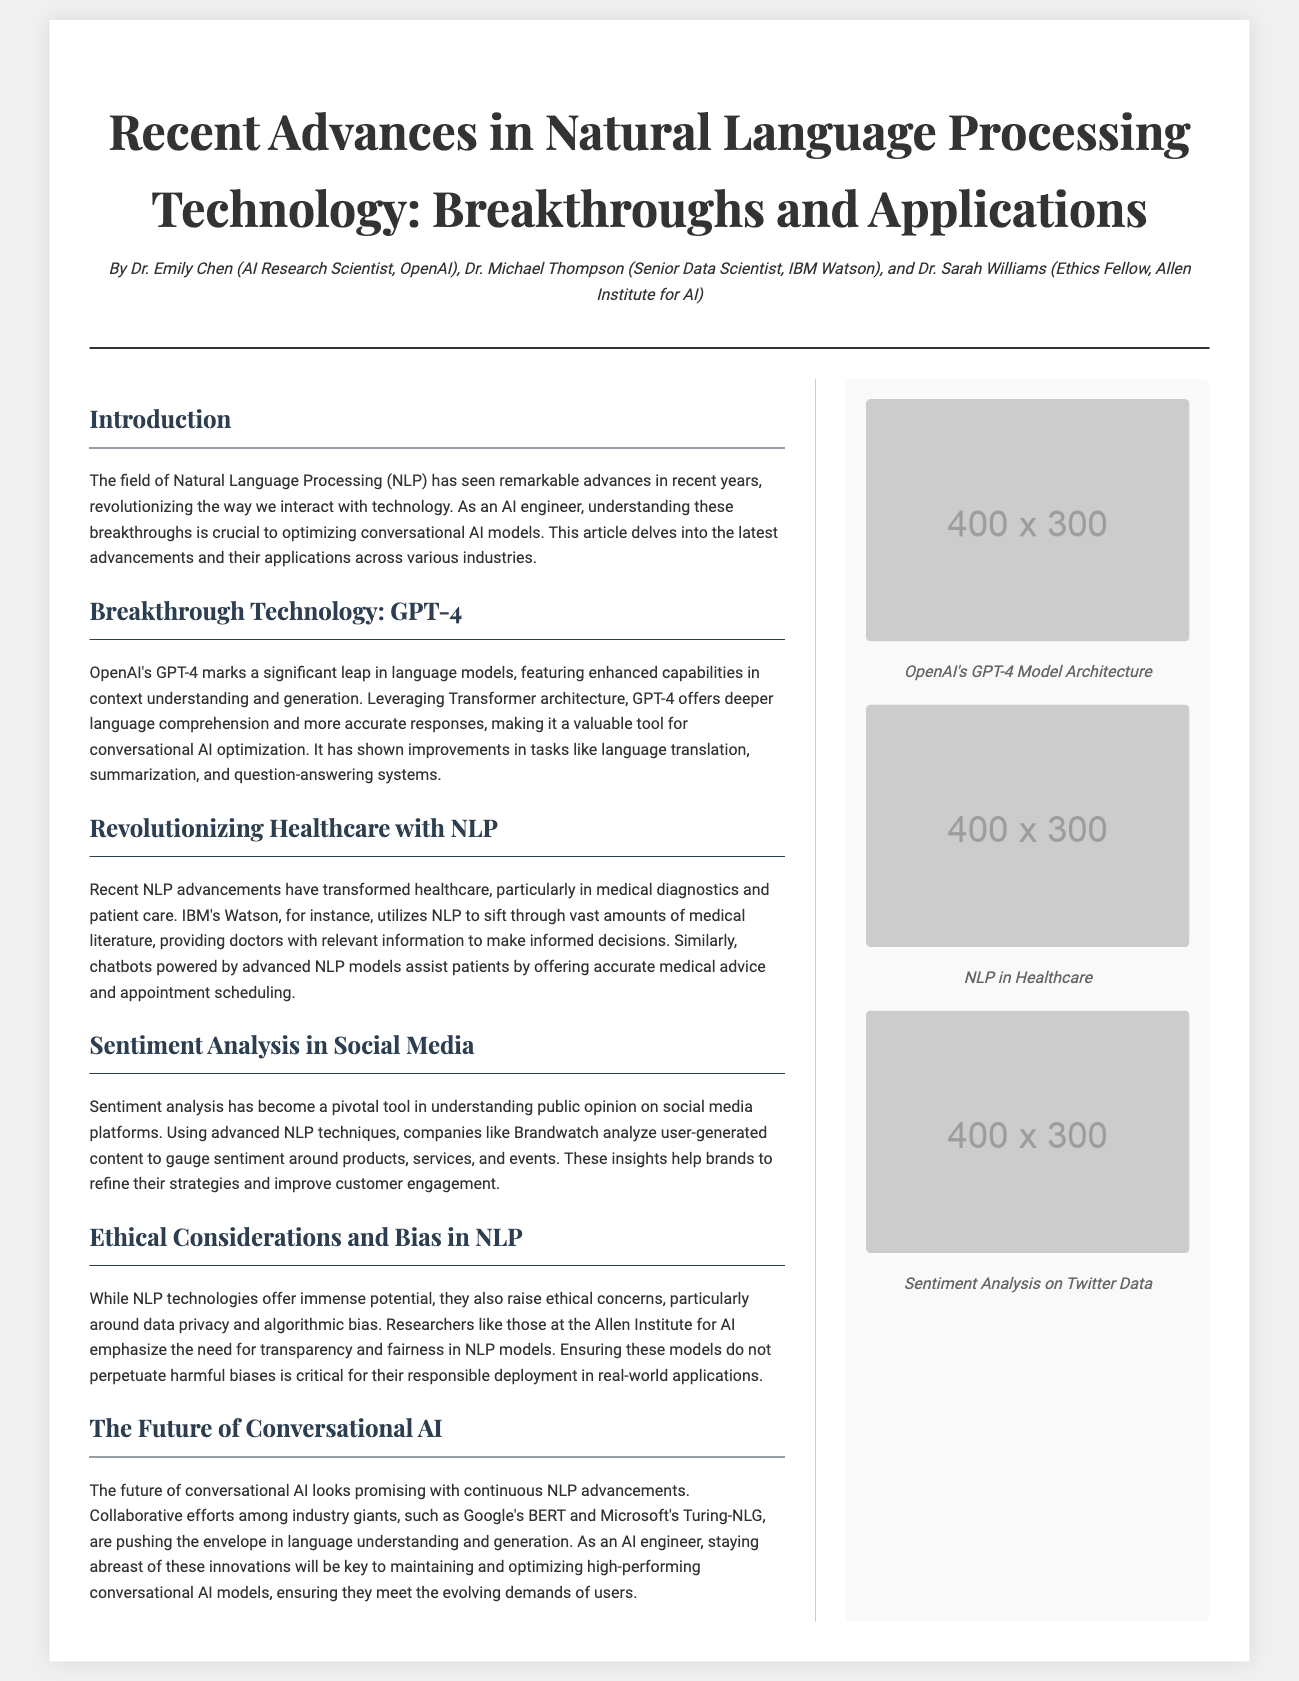What is the title of the article? The title of the article is found in the header section, which provides the central topic discussed.
Answer: Recent Advances in Natural Language Processing Technology: Breakthroughs and Applications Who is one of the authors? The authors are listed directly below the title, mentioning their names and affiliations.
Answer: Dr. Emily Chen What technology is mentioned as a breakthrough in the article? The article explicitly identifies the technology that represents a significant advancement in the field of NLP.
Answer: GPT-4 Which company utilizes NLP for medical diagnostics? The document specifies a company that is highlighted for its application of NLP in healthcare settings.
Answer: IBM What is one application of sentiment analysis mentioned? The article discusses how sentiment analysis is used in a specific context regarding user opinions.
Answer: Understanding public opinion on social media What ethical concern is raised regarding NLP technologies? The text addresses specific issues related to the responsible use of NLP technologies that can affect society.
Answer: Algorithmic bias What is the future outlook for conversational AI according to the article? The conclusion provides insight about the expected progress and innovations in the conversational AI landscape influenced by NLP advancements.
Answer: Promising How many images are included in the sidebar? The sidebar contains visual elements related to the article, which can be counted directly from the document.
Answer: Three 